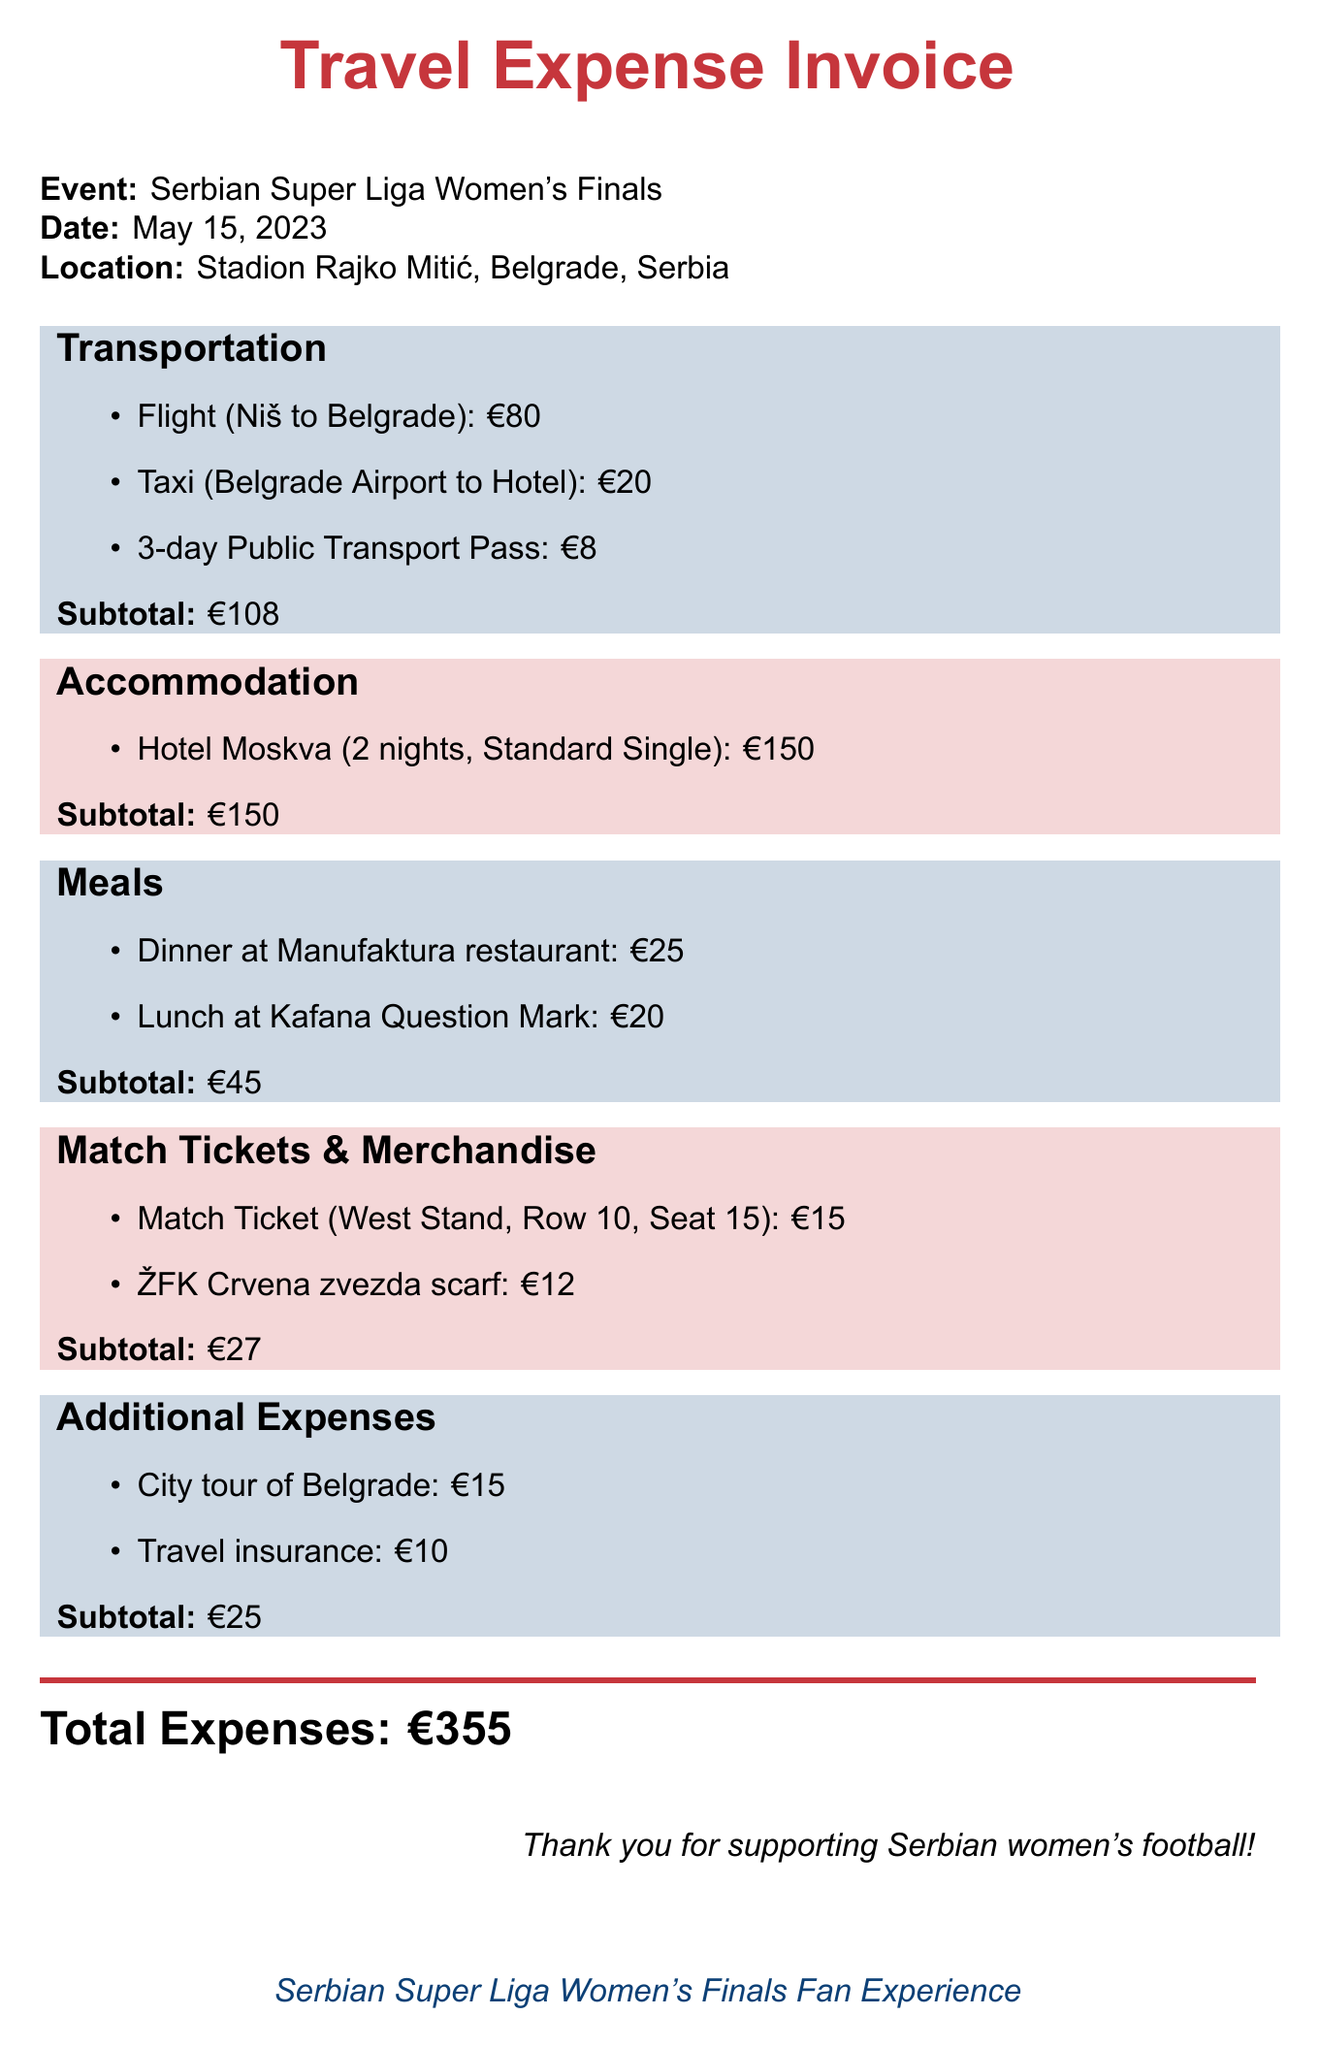What is the event name? The event name is mentioned in the invoice details section.
Answer: Serbian Super Liga Women's Finals What is the location of the event? The location is specified under the event details.
Answer: Stadion Rajko Mitić, Belgrade, Serbia How much was spent on transportation? The subtotal for transportation expenses is outlined in the document.
Answer: €108 How many nights did the accommodation last? The number of nights for accommodation is provided in the accommodation section.
Answer: 2 What was the cost of the match ticket? The cost of the match ticket is explicitly stated in the match tickets section.
Answer: €15 How much did the dinner at Manufaktura restaurant cost? The cost of the dinner is listed under the meals section.
Answer: €25 What is the total cost of the accommodation? The total cost is summarized in the accommodation section.
Answer: €150 What is the total amount spent on meals? The subtotal for meals is given in the meals section.
Answer: €45 What merchandise was purchased? The invoice includes specific merchandise purchased listed in the appropriate section.
Answer: ŽFK Crvena zvezda scarf What was the total expense amount? The total expenses are calculated and presented at the conclusion of the document.
Answer: €355 